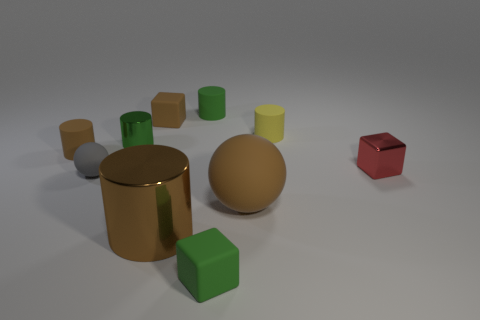Subtract all yellow cylinders. How many cylinders are left? 4 Subtract all matte blocks. How many blocks are left? 1 Subtract all cyan cylinders. Subtract all cyan spheres. How many cylinders are left? 5 Subtract all cubes. How many objects are left? 7 Subtract 1 gray spheres. How many objects are left? 9 Subtract all large cylinders. Subtract all big brown cylinders. How many objects are left? 8 Add 3 small gray objects. How many small gray objects are left? 4 Add 9 tiny green rubber cubes. How many tiny green rubber cubes exist? 10 